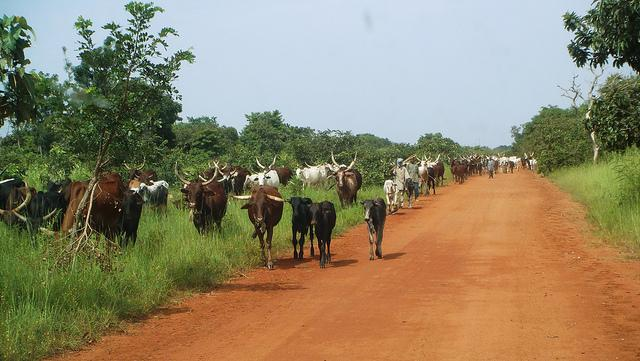What is on the dirt road?

Choices:
A) baseball players
B) eggs
C) motorcycles
D) animals animals 